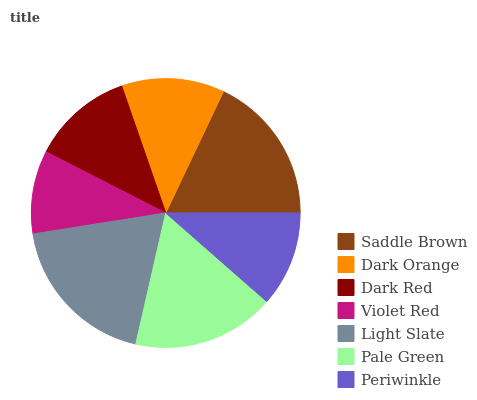Is Violet Red the minimum?
Answer yes or no. Yes. Is Light Slate the maximum?
Answer yes or no. Yes. Is Dark Orange the minimum?
Answer yes or no. No. Is Dark Orange the maximum?
Answer yes or no. No. Is Saddle Brown greater than Dark Orange?
Answer yes or no. Yes. Is Dark Orange less than Saddle Brown?
Answer yes or no. Yes. Is Dark Orange greater than Saddle Brown?
Answer yes or no. No. Is Saddle Brown less than Dark Orange?
Answer yes or no. No. Is Dark Orange the high median?
Answer yes or no. Yes. Is Dark Orange the low median?
Answer yes or no. Yes. Is Light Slate the high median?
Answer yes or no. No. Is Pale Green the low median?
Answer yes or no. No. 